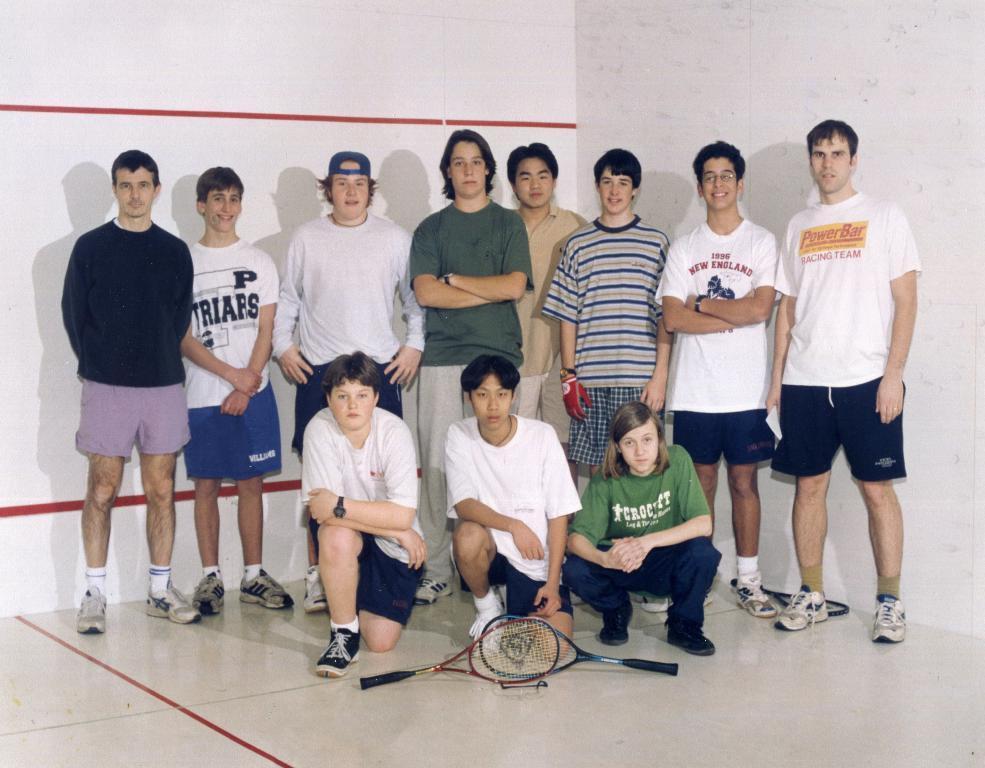In one or two sentences, can you explain what this image depicts? In this image we can see a group of people standing on the floor. One person wearing white t shirt and a blue cap. In the foreground of the image we can see two tennis rackets placed on the floor. In the background, we can see white walls. 